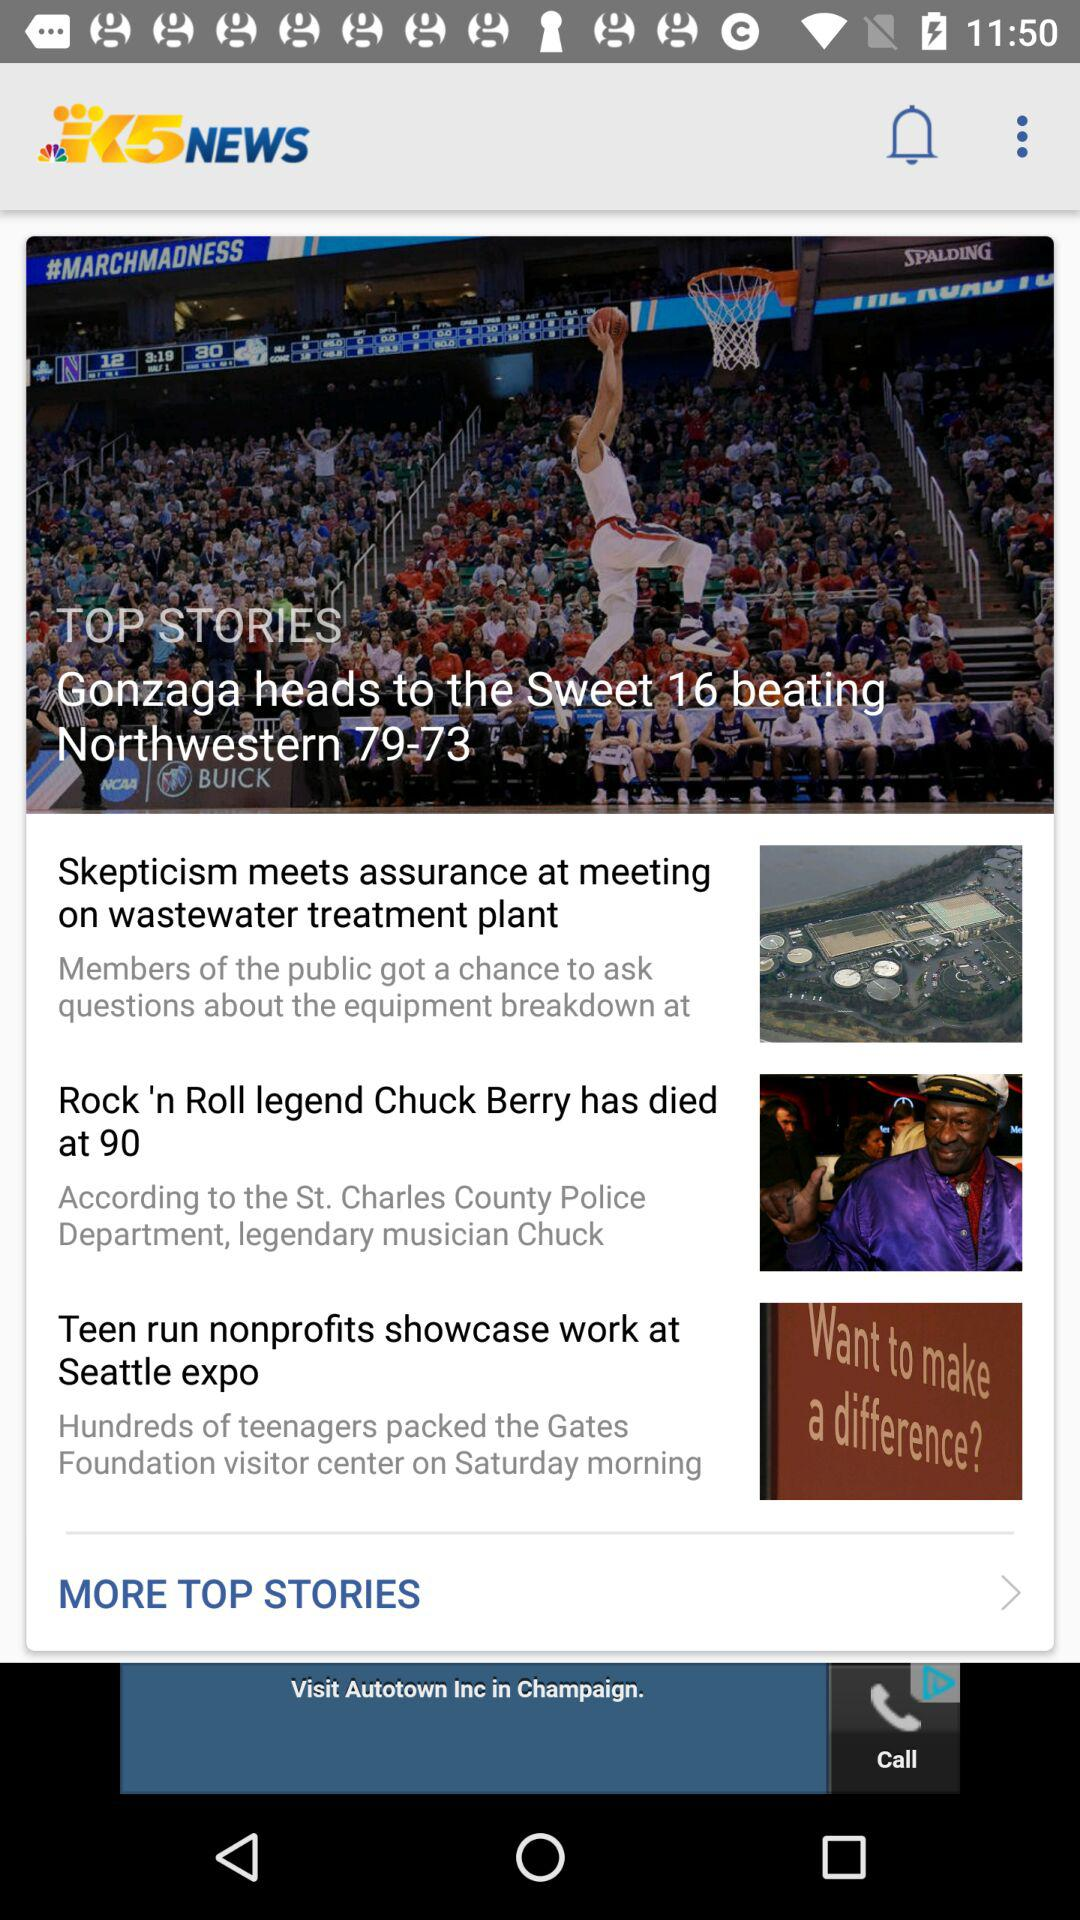How many stories are there on this page that have a picture?
Answer the question using a single word or phrase. 3 